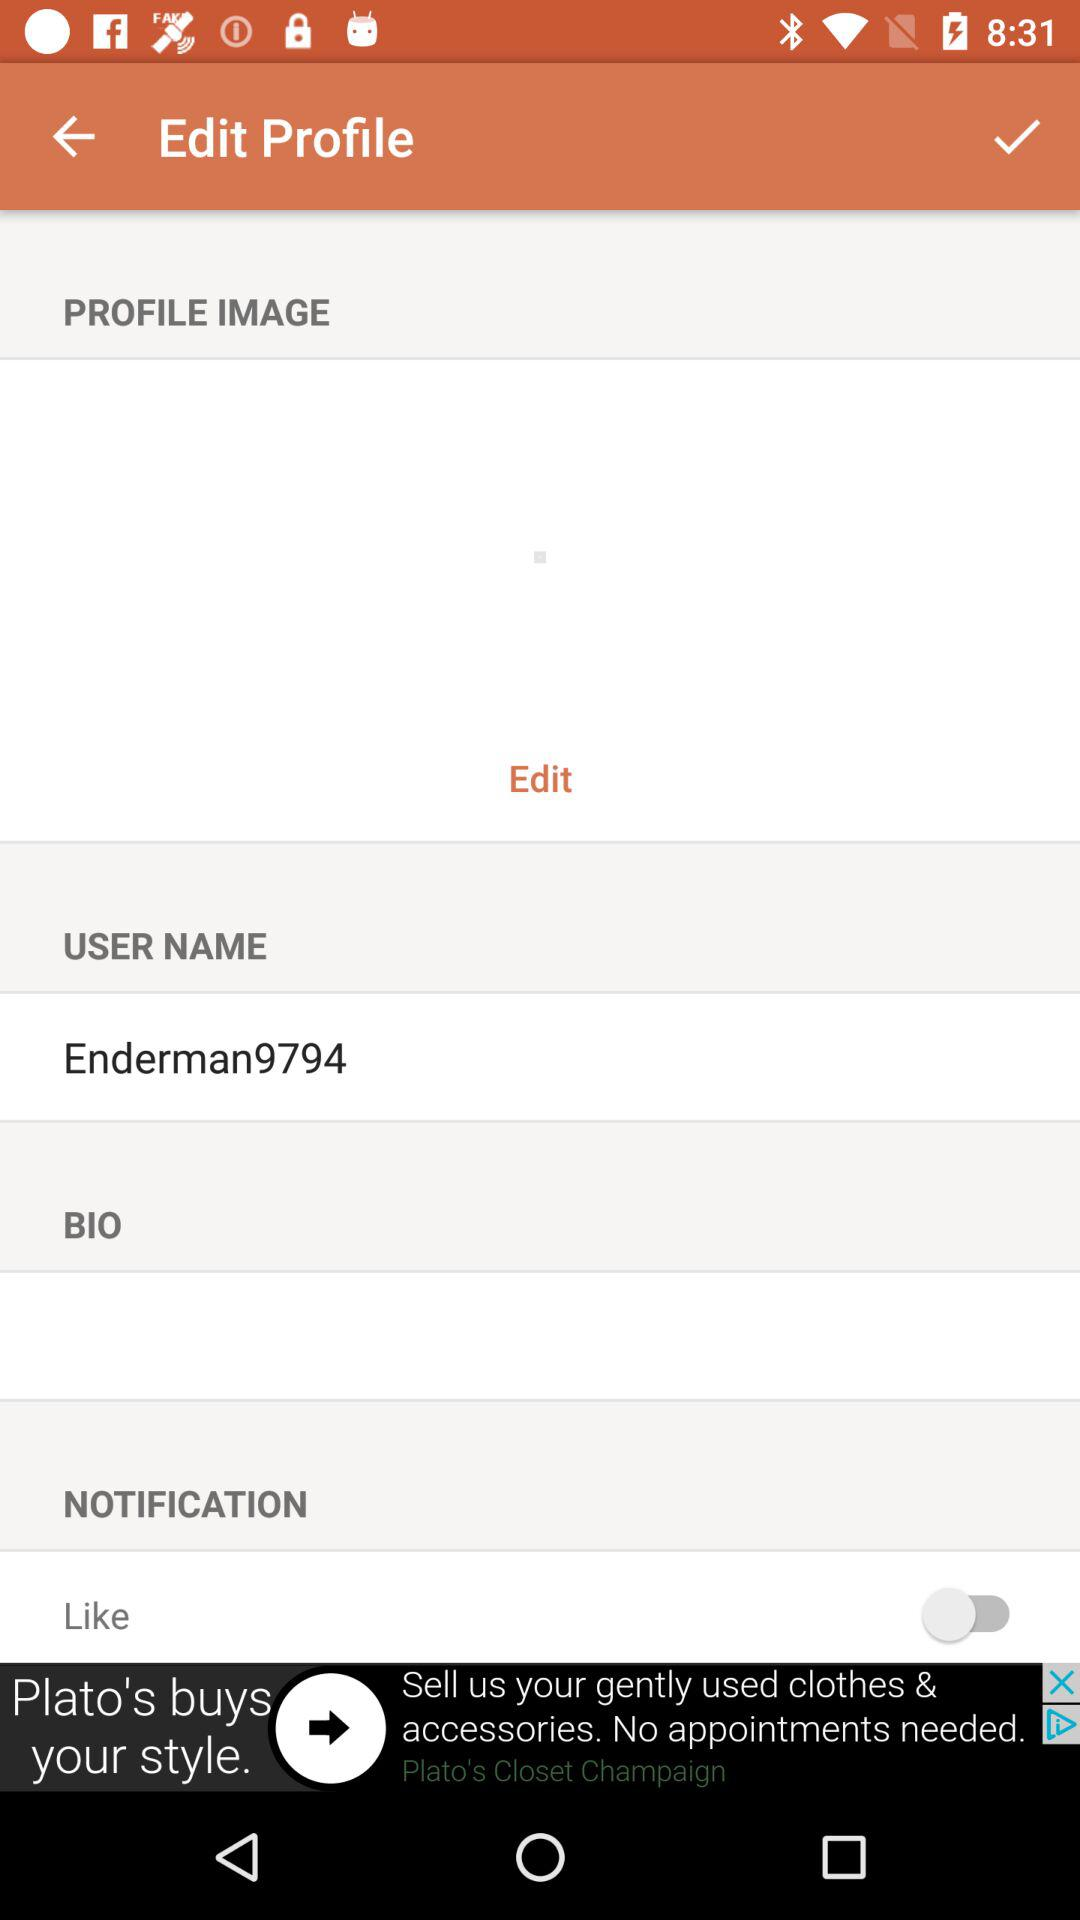What is the status of Like? The status is "off". 